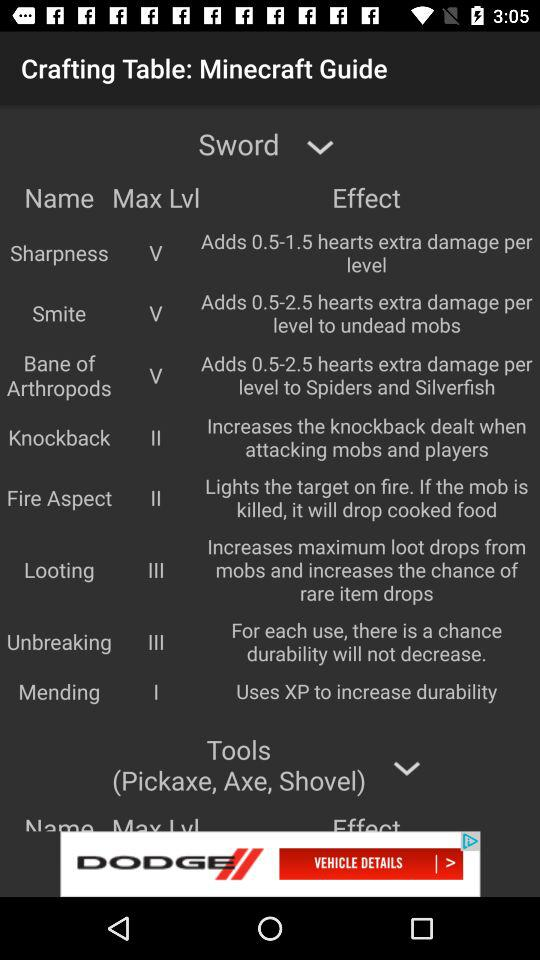What is the "Looting" maximum level? The "Looting" maximum level is 3. 